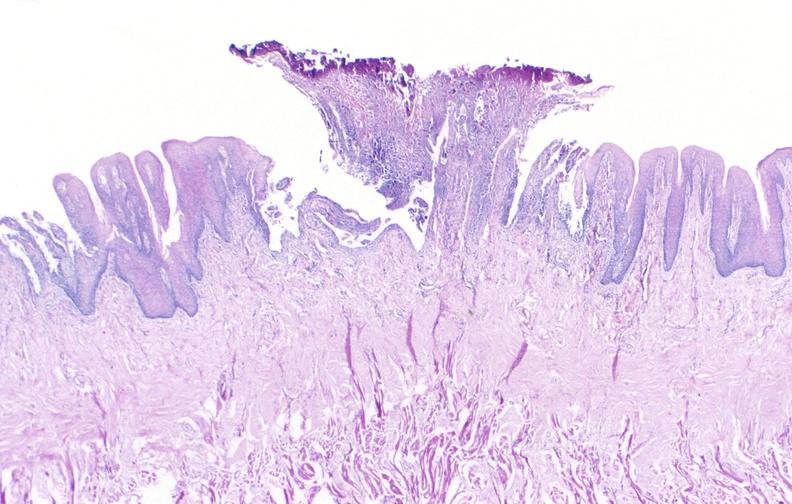does this image show tongue, herpes ulcer?
Answer the question using a single word or phrase. Yes 